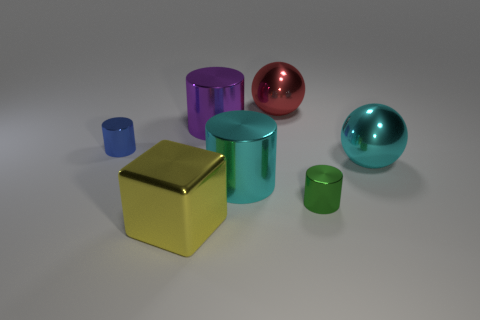Subtract all large cyan cylinders. How many cylinders are left? 3 Subtract all purple cylinders. How many cylinders are left? 3 Subtract all cylinders. How many objects are left? 3 Add 1 big yellow cylinders. How many objects exist? 8 Subtract 1 spheres. How many spheres are left? 1 Subtract all green balls. How many cyan cylinders are left? 1 Subtract all big red rubber balls. Subtract all cyan shiny balls. How many objects are left? 6 Add 4 large shiny spheres. How many large shiny spheres are left? 6 Add 4 big gray matte cylinders. How many big gray matte cylinders exist? 4 Subtract 0 purple blocks. How many objects are left? 7 